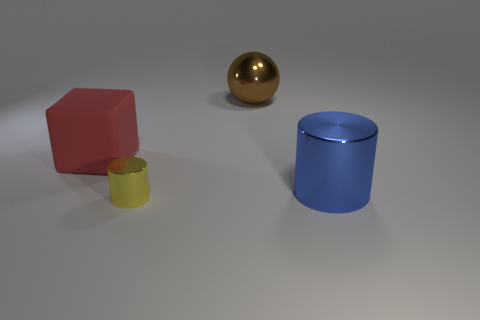Subtract all purple blocks. Subtract all blue cylinders. How many blocks are left? 1 Add 2 tiny yellow metal objects. How many objects exist? 6 Subtract all blocks. How many objects are left? 3 Add 3 big shiny objects. How many big shiny objects are left? 5 Add 1 brown cubes. How many brown cubes exist? 1 Subtract 1 brown balls. How many objects are left? 3 Subtract all yellow cylinders. Subtract all red matte blocks. How many objects are left? 2 